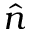<formula> <loc_0><loc_0><loc_500><loc_500>\hat { n }</formula> 